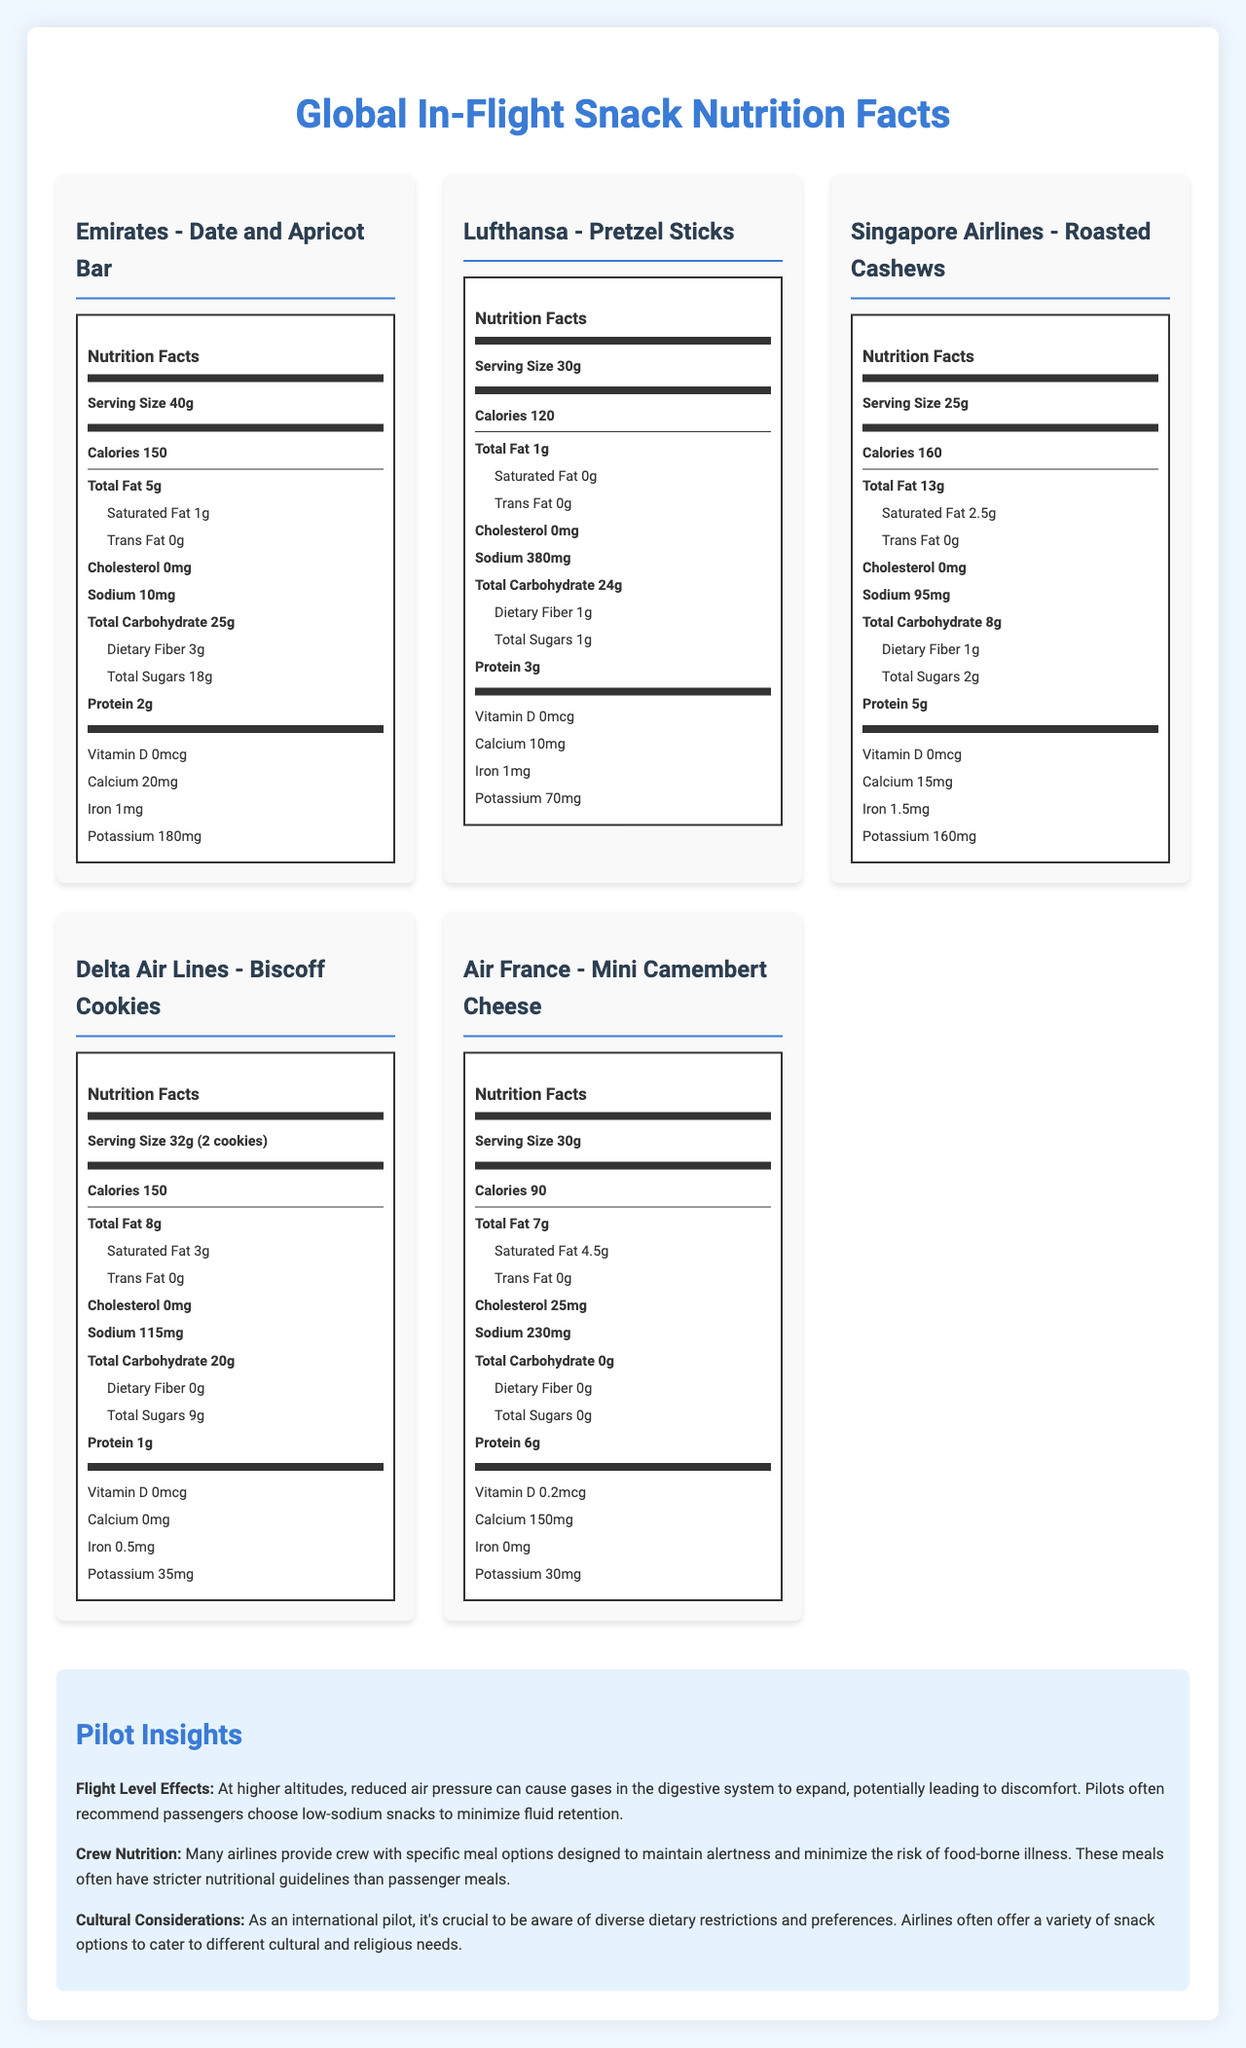What is the serving size of Emirates' Date and Apricot Bar? The serving size of Emirates' Date and Apricot Bar is indicated as 40g in the document.
Answer: 40g Which snack has the highest amount of total fat? A. Emirates' Date and Apricot Bar B. Lufthansa's Pretzel Sticks C. Singapore Airlines' Roasted Cashews D. Delta Air Lines' Biscoff Cookies E. Air France's Mini Camembert Cheese Singapore Airlines' Roasted Cashews have the highest total fat content at 13g.
Answer: C How much cholesterol does the Mini Camembert Cheese from Air France contain? The Mini Camembert Cheese from Air France contains 25mg of cholesterol.
Answer: 25mg Which snack has the highest sodium content? A. Emirates' Date and Apricot Bar B. Lufthansa's Pretzel Sticks C. Singapore Airlines' Roasted Cashews D. Delta Air Lines' Biscoff Cookies E. Air France's Mini Camembert Cheese Lufthansa's Pretzel Sticks have the highest sodium content at 380mg.
Answer: B Does Delta Air Lines' Biscoff Cookies contain any dietary fiber? Delta Air Lines' Biscoff Cookies do not contain any dietary fiber, as indicated by the value of 0g in the document.
Answer: No What are some of the regulations regarding in-flight snack nutrition labeling in the EU? The document states that Regulation (EU) No 1169/2011 mandates nutrition labeling for pre-packaged foods served on flights.
Answer: Regulation (EU) No 1169/2011 requires mandatory nutrition labeling for pre-packaged foods, including in-flight snacks Which snack has the highest protein content? Air France's Mini Camembert Cheese has the highest protein content, with 6g of protein.
Answer: Air France's Mini Camembert Cheese Is there any snack without any sugar content? Air France's Mini Camembert Cheese has 0g of total sugars, indicating it has no sugar content.
Answer: Yes Summarize the main insights provided by the document. The document highlights the nutritional content of snacks served by different airlines, regulatory frameworks for labeling, and pilot recommendations for healthy eating at high altitudes.
Answer: The document provides comparative nutrition facts labels for in-flight snacks from various global airlines, along with international regulations on nutrition labeling and pilot insights on dietary considerations during flights. What is the role of potassium in the snacks, and how does it vary across different snacks? The document lists potassium content for each snack but does not explain the role of potassium or its specific benefits in the context of these snacks, thus more information is needed.
Answer: Cannot be determined 